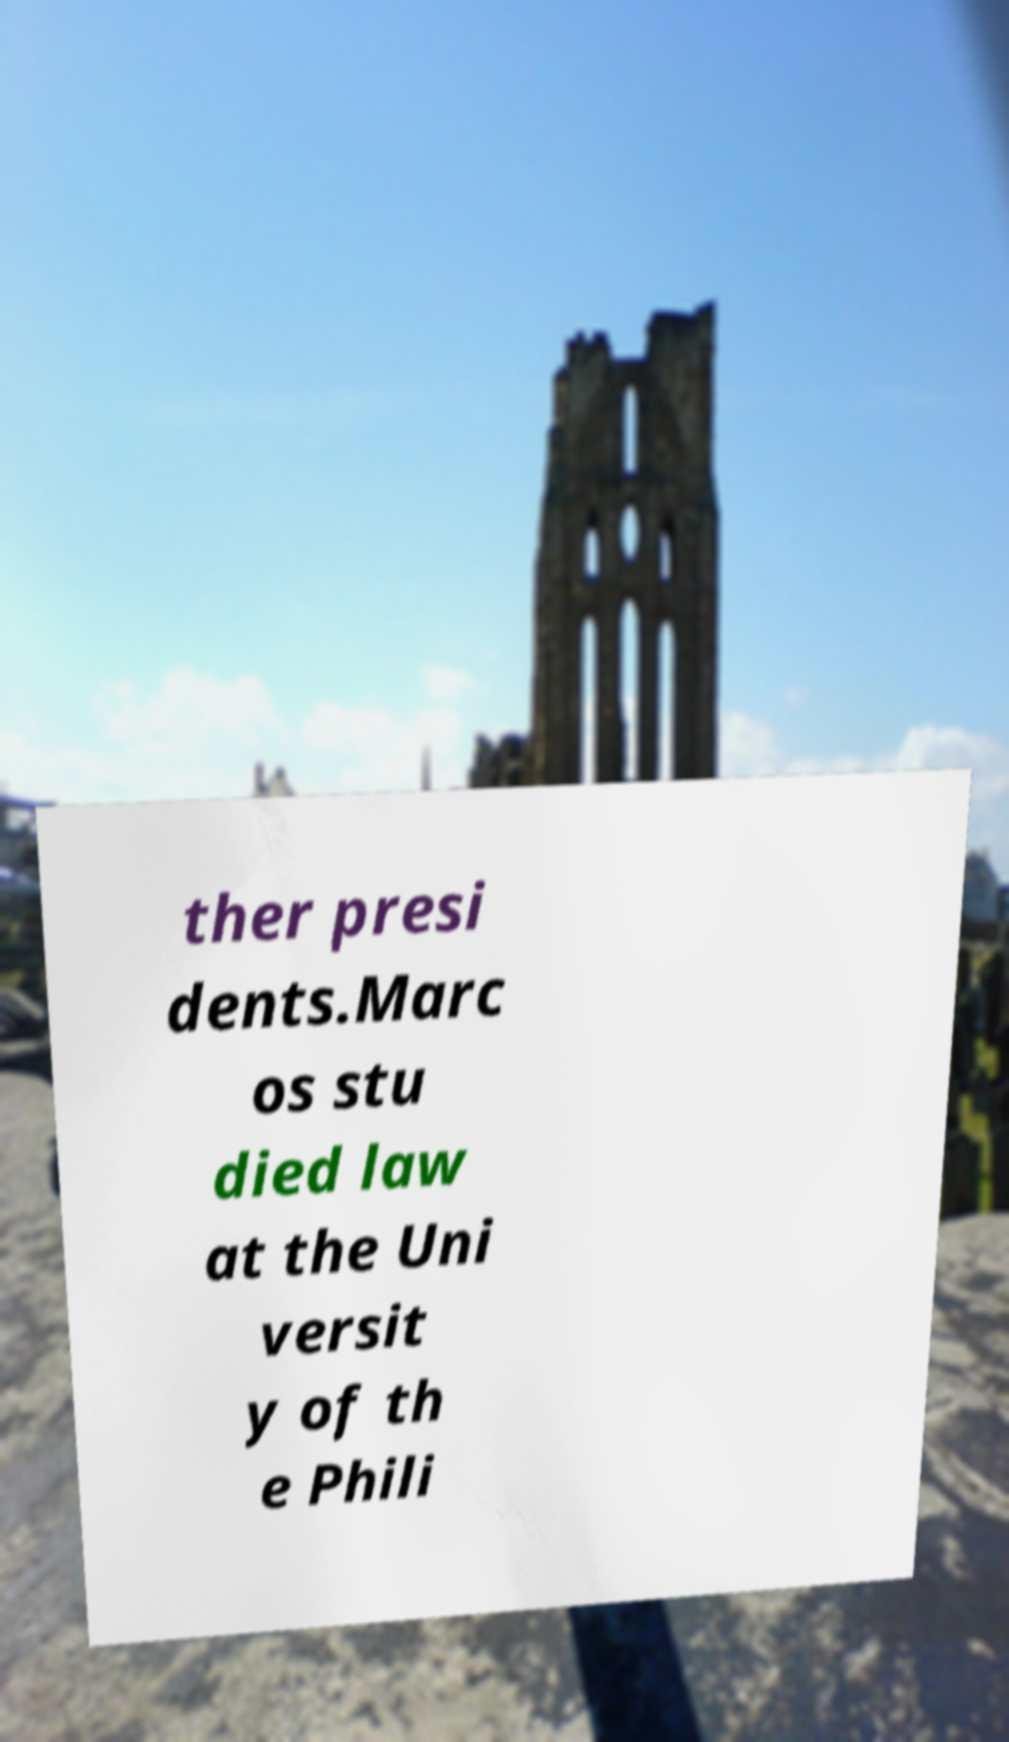There's text embedded in this image that I need extracted. Can you transcribe it verbatim? ther presi dents.Marc os stu died law at the Uni versit y of th e Phili 